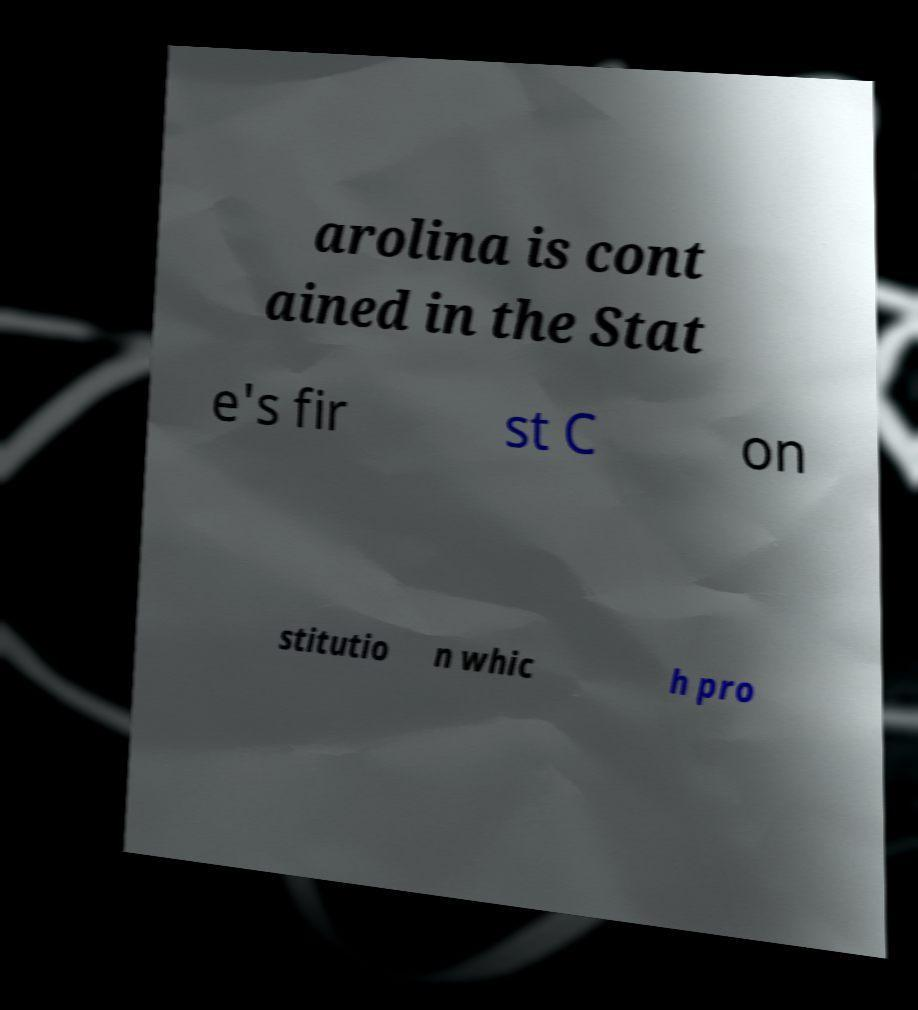Can you read and provide the text displayed in the image?This photo seems to have some interesting text. Can you extract and type it out for me? arolina is cont ained in the Stat e's fir st C on stitutio n whic h pro 